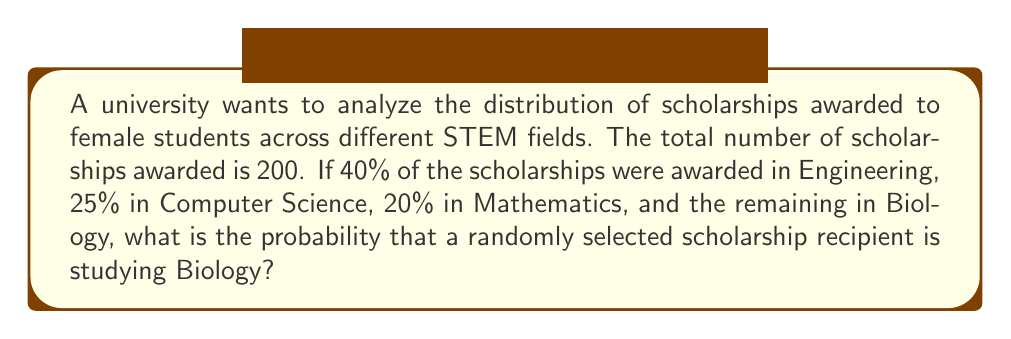Show me your answer to this math problem. Let's approach this step-by-step:

1) First, let's calculate the number of scholarships awarded in each field:

   Engineering: $40\% \text{ of } 200 = 0.40 \times 200 = 80$ scholarships
   Computer Science: $25\% \text{ of } 200 = 0.25 \times 200 = 50$ scholarships
   Mathematics: $20\% \text{ of } 200 = 0.20 \times 200 = 40$ scholarships

2) Now, let's find the number of scholarships awarded in Biology:

   Total scholarships = Engineering + Computer Science + Mathematics + Biology
   $200 = 80 + 50 + 40 + \text{Biology}$
   $\text{Biology} = 200 - (80 + 50 + 40) = 200 - 170 = 30$ scholarships

3) To find the probability, we divide the number of favorable outcomes by the total number of possible outcomes:

   $P(\text{Biology}) = \frac{\text{Number of Biology scholarships}}{\text{Total number of scholarships}} = \frac{30}{200}$

4) Simplify the fraction:

   $\frac{30}{200} = \frac{3}{20} = 0.15$

Therefore, the probability that a randomly selected scholarship recipient is studying Biology is $\frac{3}{20}$ or 0.15 or 15%.
Answer: $\frac{3}{20}$ 